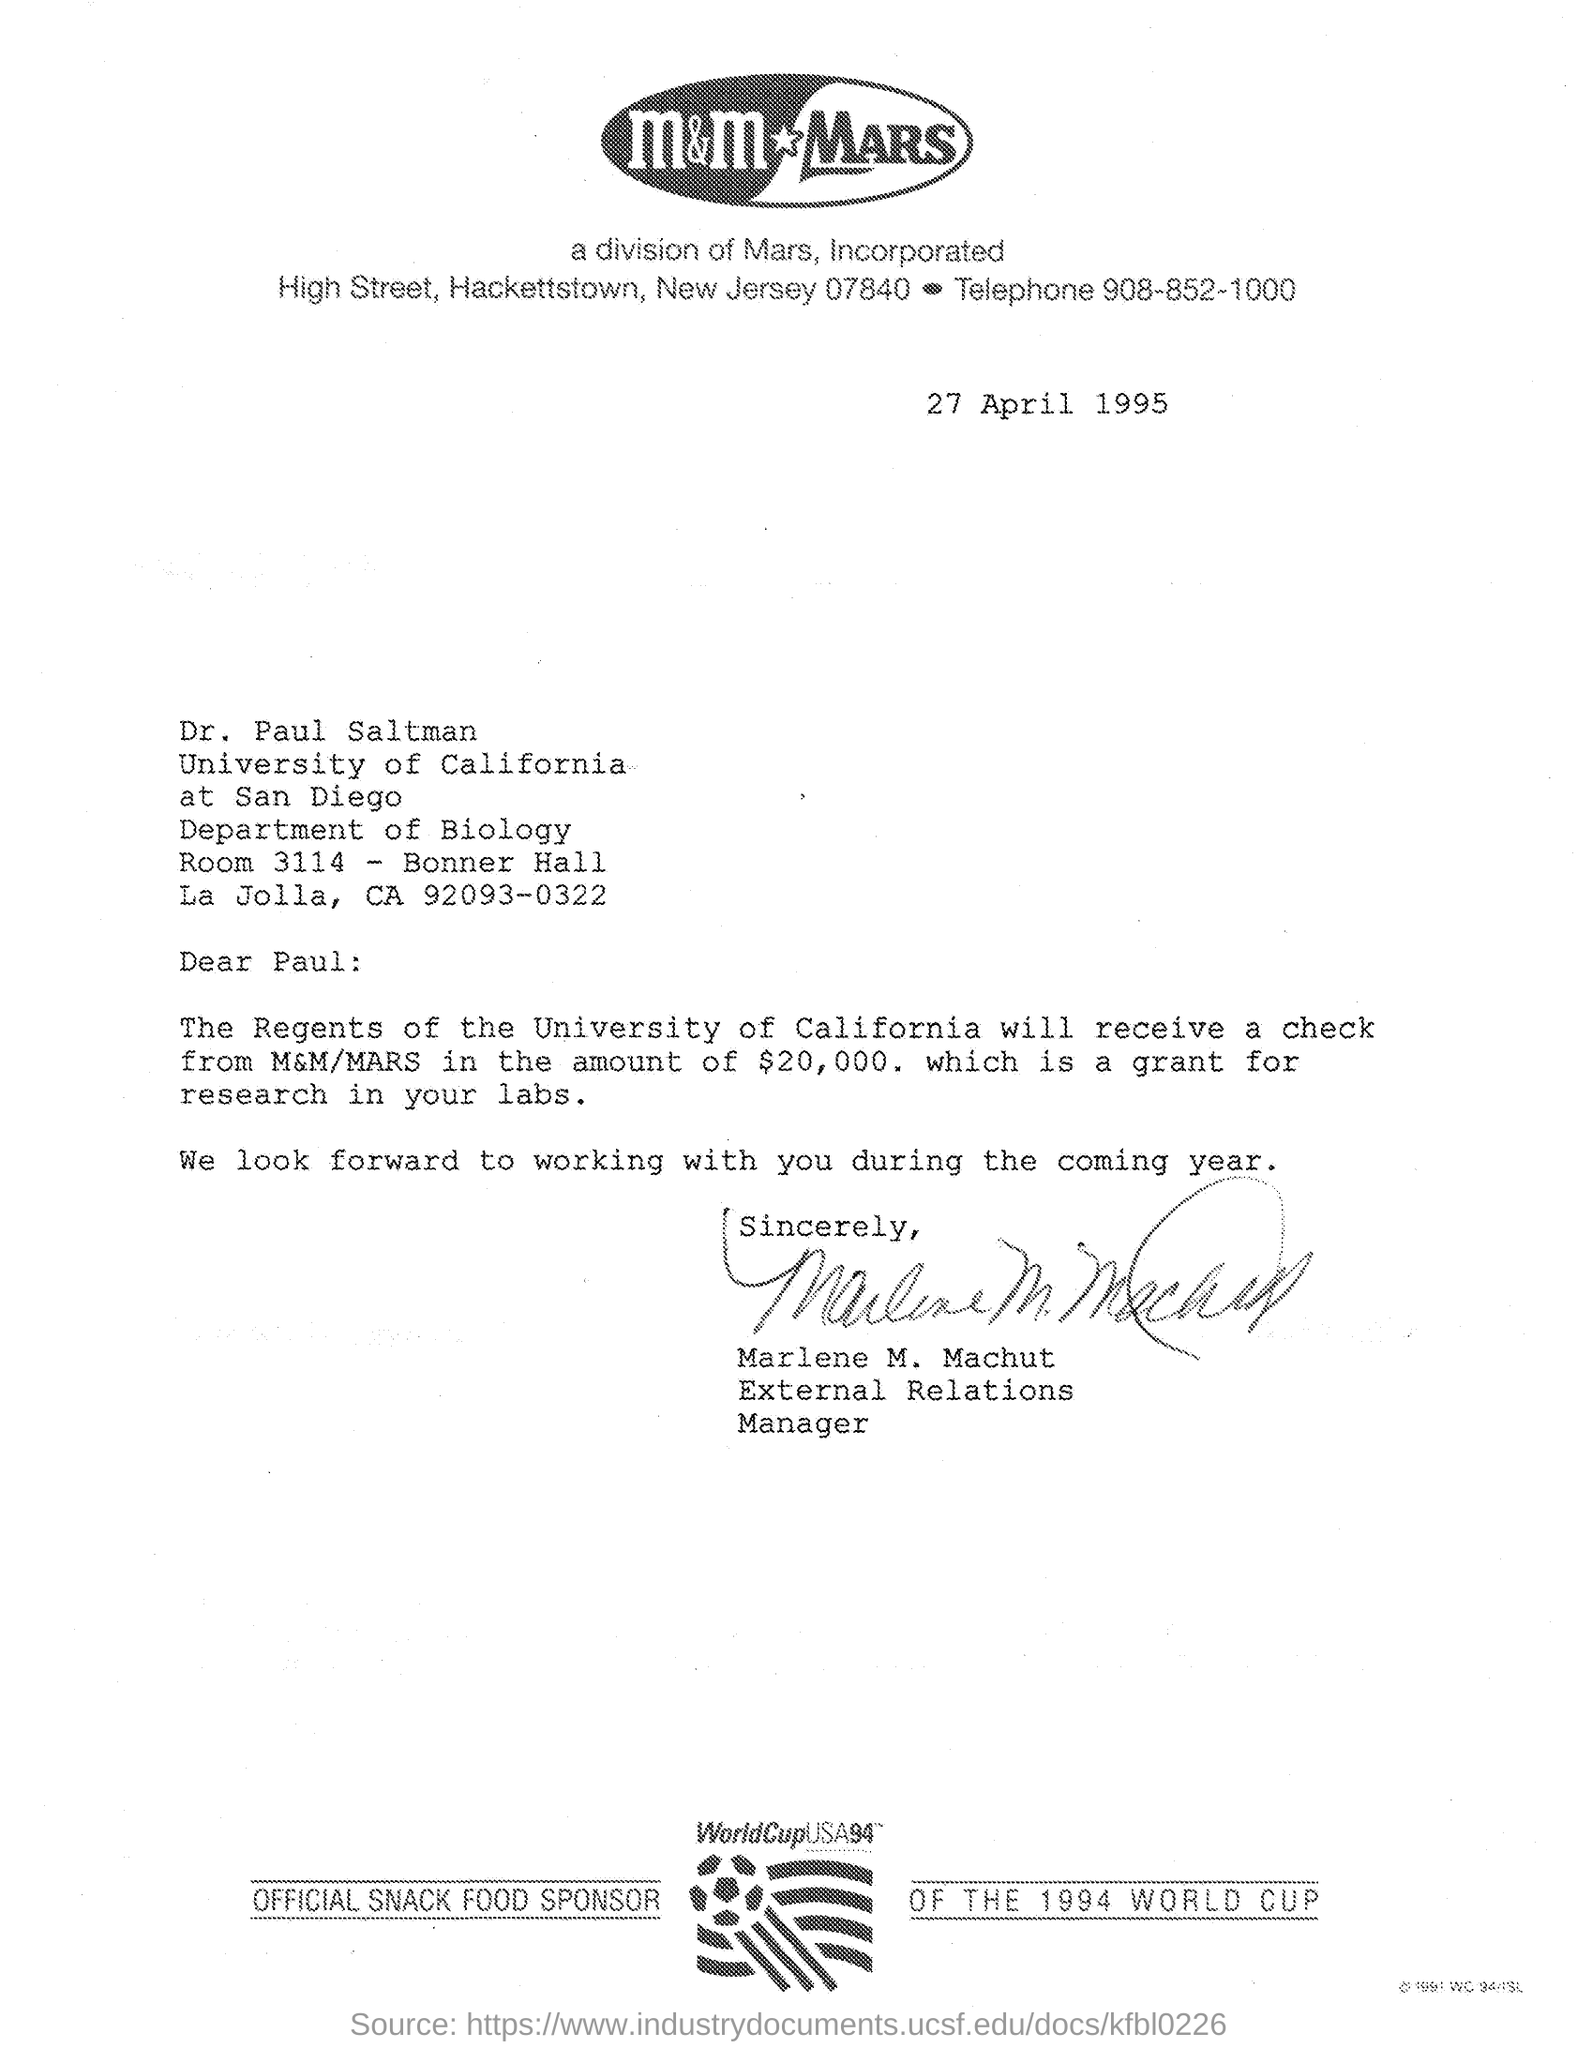Outline some significant characteristics in this image. The telephone number mentioned in the given letter is 908-852-1000. The date mentioned in the given letter is April 27, 1995. The department mentioned in the given letter is the Department of Biology. The sign at the end of the letter belonged to Marlene M. Machut. Dr. Paul Saltman belongs to the University of California. 